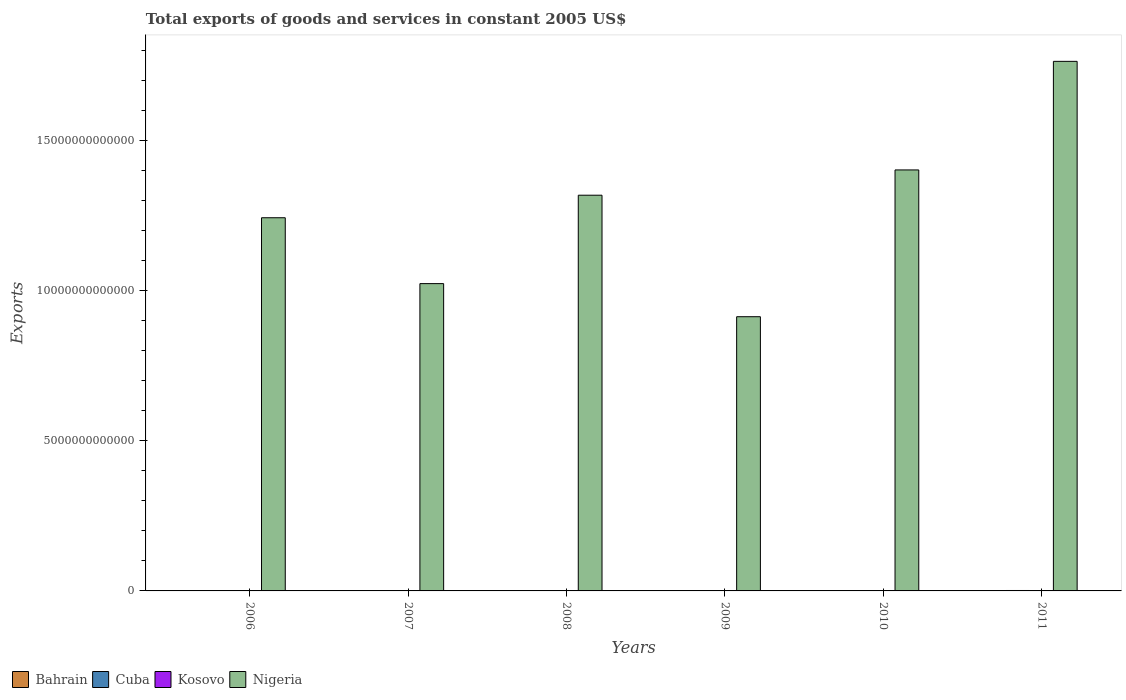What is the label of the 4th group of bars from the left?
Provide a short and direct response. 2009. What is the total exports of goods and services in Nigeria in 2009?
Offer a terse response. 9.13e+12. Across all years, what is the maximum total exports of goods and services in Cuba?
Keep it short and to the point. 1.41e+1. Across all years, what is the minimum total exports of goods and services in Bahrain?
Make the answer very short. 6.45e+09. In which year was the total exports of goods and services in Nigeria maximum?
Your answer should be very brief. 2011. What is the total total exports of goods and services in Bahrain in the graph?
Offer a terse response. 3.94e+1. What is the difference between the total exports of goods and services in Bahrain in 2006 and that in 2010?
Your answer should be compact. -2.68e+08. What is the difference between the total exports of goods and services in Nigeria in 2008 and the total exports of goods and services in Cuba in 2009?
Make the answer very short. 1.32e+13. What is the average total exports of goods and services in Cuba per year?
Provide a short and direct response. 1.17e+1. In the year 2011, what is the difference between the total exports of goods and services in Cuba and total exports of goods and services in Nigeria?
Make the answer very short. -1.76e+13. In how many years, is the total exports of goods and services in Nigeria greater than 3000000000000 US$?
Your answer should be very brief. 6. What is the ratio of the total exports of goods and services in Cuba in 2007 to that in 2011?
Give a very brief answer. 0.74. Is the total exports of goods and services in Cuba in 2008 less than that in 2011?
Your response must be concise. Yes. What is the difference between the highest and the second highest total exports of goods and services in Cuba?
Your answer should be compact. 5.28e+08. What is the difference between the highest and the lowest total exports of goods and services in Kosovo?
Offer a terse response. 3.19e+08. In how many years, is the total exports of goods and services in Nigeria greater than the average total exports of goods and services in Nigeria taken over all years?
Give a very brief answer. 3. Is the sum of the total exports of goods and services in Kosovo in 2009 and 2010 greater than the maximum total exports of goods and services in Nigeria across all years?
Provide a short and direct response. No. Is it the case that in every year, the sum of the total exports of goods and services in Kosovo and total exports of goods and services in Cuba is greater than the sum of total exports of goods and services in Bahrain and total exports of goods and services in Nigeria?
Ensure brevity in your answer.  No. What does the 3rd bar from the left in 2011 represents?
Your answer should be compact. Kosovo. What does the 2nd bar from the right in 2009 represents?
Your response must be concise. Kosovo. Is it the case that in every year, the sum of the total exports of goods and services in Bahrain and total exports of goods and services in Nigeria is greater than the total exports of goods and services in Cuba?
Your answer should be compact. Yes. How many bars are there?
Keep it short and to the point. 24. Are all the bars in the graph horizontal?
Ensure brevity in your answer.  No. How many years are there in the graph?
Your response must be concise. 6. What is the difference between two consecutive major ticks on the Y-axis?
Your response must be concise. 5.00e+12. Are the values on the major ticks of Y-axis written in scientific E-notation?
Offer a terse response. No. Does the graph contain any zero values?
Give a very brief answer. No. How are the legend labels stacked?
Make the answer very short. Horizontal. What is the title of the graph?
Your answer should be very brief. Total exports of goods and services in constant 2005 US$. What is the label or title of the Y-axis?
Your answer should be compact. Exports. What is the Exports of Bahrain in 2006?
Keep it short and to the point. 6.45e+09. What is the Exports in Cuba in 2006?
Offer a very short reply. 9.08e+09. What is the Exports of Kosovo in 2006?
Your response must be concise. 4.81e+08. What is the Exports in Nigeria in 2006?
Your answer should be very brief. 1.24e+13. What is the Exports in Bahrain in 2007?
Your answer should be very brief. 6.48e+09. What is the Exports of Cuba in 2007?
Your answer should be very brief. 1.03e+1. What is the Exports of Kosovo in 2007?
Offer a very short reply. 6.08e+08. What is the Exports of Nigeria in 2007?
Your response must be concise. 1.02e+13. What is the Exports of Bahrain in 2008?
Your answer should be compact. 6.53e+09. What is the Exports of Cuba in 2008?
Keep it short and to the point. 1.15e+1. What is the Exports of Kosovo in 2008?
Keep it short and to the point. 6.09e+08. What is the Exports of Nigeria in 2008?
Your answer should be compact. 1.32e+13. What is the Exports in Bahrain in 2009?
Give a very brief answer. 6.55e+09. What is the Exports of Cuba in 2009?
Provide a succinct answer. 1.19e+1. What is the Exports in Kosovo in 2009?
Offer a very short reply. 6.85e+08. What is the Exports in Nigeria in 2009?
Keep it short and to the point. 9.13e+12. What is the Exports of Bahrain in 2010?
Offer a terse response. 6.72e+09. What is the Exports of Cuba in 2010?
Make the answer very short. 1.35e+1. What is the Exports of Kosovo in 2010?
Your answer should be very brief. 7.70e+08. What is the Exports of Nigeria in 2010?
Give a very brief answer. 1.40e+13. What is the Exports in Bahrain in 2011?
Your answer should be very brief. 6.64e+09. What is the Exports in Cuba in 2011?
Provide a short and direct response. 1.41e+1. What is the Exports of Kosovo in 2011?
Provide a short and direct response. 8.00e+08. What is the Exports in Nigeria in 2011?
Your answer should be very brief. 1.76e+13. Across all years, what is the maximum Exports of Bahrain?
Your response must be concise. 6.72e+09. Across all years, what is the maximum Exports in Cuba?
Your response must be concise. 1.41e+1. Across all years, what is the maximum Exports in Kosovo?
Provide a succinct answer. 8.00e+08. Across all years, what is the maximum Exports of Nigeria?
Make the answer very short. 1.76e+13. Across all years, what is the minimum Exports in Bahrain?
Keep it short and to the point. 6.45e+09. Across all years, what is the minimum Exports in Cuba?
Offer a very short reply. 9.08e+09. Across all years, what is the minimum Exports in Kosovo?
Provide a succinct answer. 4.81e+08. Across all years, what is the minimum Exports of Nigeria?
Your answer should be compact. 9.13e+12. What is the total Exports of Bahrain in the graph?
Your answer should be very brief. 3.94e+1. What is the total Exports of Cuba in the graph?
Ensure brevity in your answer.  7.04e+1. What is the total Exports of Kosovo in the graph?
Ensure brevity in your answer.  3.95e+09. What is the total Exports in Nigeria in the graph?
Give a very brief answer. 7.66e+13. What is the difference between the Exports in Bahrain in 2006 and that in 2007?
Your answer should be compact. -2.92e+07. What is the difference between the Exports of Cuba in 2006 and that in 2007?
Provide a succinct answer. -1.25e+09. What is the difference between the Exports in Kosovo in 2006 and that in 2007?
Your answer should be compact. -1.27e+08. What is the difference between the Exports in Nigeria in 2006 and that in 2007?
Offer a terse response. 2.19e+12. What is the difference between the Exports in Bahrain in 2006 and that in 2008?
Your answer should be compact. -7.32e+07. What is the difference between the Exports of Cuba in 2006 and that in 2008?
Make the answer very short. -2.45e+09. What is the difference between the Exports in Kosovo in 2006 and that in 2008?
Your answer should be very brief. -1.28e+08. What is the difference between the Exports in Nigeria in 2006 and that in 2008?
Offer a terse response. -7.50e+11. What is the difference between the Exports in Bahrain in 2006 and that in 2009?
Offer a very short reply. -9.60e+07. What is the difference between the Exports of Cuba in 2006 and that in 2009?
Your answer should be compact. -2.81e+09. What is the difference between the Exports of Kosovo in 2006 and that in 2009?
Provide a succinct answer. -2.03e+08. What is the difference between the Exports of Nigeria in 2006 and that in 2009?
Your answer should be compact. 3.29e+12. What is the difference between the Exports in Bahrain in 2006 and that in 2010?
Offer a terse response. -2.68e+08. What is the difference between the Exports of Cuba in 2006 and that in 2010?
Your answer should be compact. -4.45e+09. What is the difference between the Exports of Kosovo in 2006 and that in 2010?
Offer a terse response. -2.89e+08. What is the difference between the Exports of Nigeria in 2006 and that in 2010?
Your answer should be very brief. -1.59e+12. What is the difference between the Exports in Bahrain in 2006 and that in 2011?
Your answer should be compact. -1.88e+08. What is the difference between the Exports of Cuba in 2006 and that in 2011?
Make the answer very short. -4.98e+09. What is the difference between the Exports of Kosovo in 2006 and that in 2011?
Ensure brevity in your answer.  -3.19e+08. What is the difference between the Exports of Nigeria in 2006 and that in 2011?
Keep it short and to the point. -5.21e+12. What is the difference between the Exports in Bahrain in 2007 and that in 2008?
Make the answer very short. -4.40e+07. What is the difference between the Exports in Cuba in 2007 and that in 2008?
Your answer should be very brief. -1.20e+09. What is the difference between the Exports in Kosovo in 2007 and that in 2008?
Your answer should be compact. -5.00e+05. What is the difference between the Exports in Nigeria in 2007 and that in 2008?
Ensure brevity in your answer.  -2.94e+12. What is the difference between the Exports in Bahrain in 2007 and that in 2009?
Make the answer very short. -6.68e+07. What is the difference between the Exports of Cuba in 2007 and that in 2009?
Keep it short and to the point. -1.56e+09. What is the difference between the Exports in Kosovo in 2007 and that in 2009?
Your response must be concise. -7.64e+07. What is the difference between the Exports in Nigeria in 2007 and that in 2009?
Provide a short and direct response. 1.10e+12. What is the difference between the Exports of Bahrain in 2007 and that in 2010?
Give a very brief answer. -2.39e+08. What is the difference between the Exports in Cuba in 2007 and that in 2010?
Give a very brief answer. -3.20e+09. What is the difference between the Exports of Kosovo in 2007 and that in 2010?
Give a very brief answer. -1.62e+08. What is the difference between the Exports in Nigeria in 2007 and that in 2010?
Ensure brevity in your answer.  -3.78e+12. What is the difference between the Exports in Bahrain in 2007 and that in 2011?
Offer a terse response. -1.59e+08. What is the difference between the Exports in Cuba in 2007 and that in 2011?
Give a very brief answer. -3.72e+09. What is the difference between the Exports of Kosovo in 2007 and that in 2011?
Give a very brief answer. -1.92e+08. What is the difference between the Exports in Nigeria in 2007 and that in 2011?
Provide a succinct answer. -7.40e+12. What is the difference between the Exports in Bahrain in 2008 and that in 2009?
Your answer should be very brief. -2.28e+07. What is the difference between the Exports in Cuba in 2008 and that in 2009?
Ensure brevity in your answer.  -3.59e+08. What is the difference between the Exports in Kosovo in 2008 and that in 2009?
Provide a succinct answer. -7.59e+07. What is the difference between the Exports of Nigeria in 2008 and that in 2009?
Your answer should be very brief. 4.04e+12. What is the difference between the Exports in Bahrain in 2008 and that in 2010?
Ensure brevity in your answer.  -1.95e+08. What is the difference between the Exports in Cuba in 2008 and that in 2010?
Your answer should be very brief. -2.00e+09. What is the difference between the Exports of Kosovo in 2008 and that in 2010?
Offer a terse response. -1.62e+08. What is the difference between the Exports in Nigeria in 2008 and that in 2010?
Make the answer very short. -8.42e+11. What is the difference between the Exports of Bahrain in 2008 and that in 2011?
Keep it short and to the point. -1.15e+08. What is the difference between the Exports of Cuba in 2008 and that in 2011?
Provide a short and direct response. -2.53e+09. What is the difference between the Exports of Kosovo in 2008 and that in 2011?
Your response must be concise. -1.91e+08. What is the difference between the Exports in Nigeria in 2008 and that in 2011?
Give a very brief answer. -4.46e+12. What is the difference between the Exports of Bahrain in 2009 and that in 2010?
Your answer should be compact. -1.72e+08. What is the difference between the Exports of Cuba in 2009 and that in 2010?
Make the answer very short. -1.64e+09. What is the difference between the Exports in Kosovo in 2009 and that in 2010?
Offer a terse response. -8.56e+07. What is the difference between the Exports in Nigeria in 2009 and that in 2010?
Make the answer very short. -4.89e+12. What is the difference between the Exports of Bahrain in 2009 and that in 2011?
Keep it short and to the point. -9.23e+07. What is the difference between the Exports in Cuba in 2009 and that in 2011?
Keep it short and to the point. -2.17e+09. What is the difference between the Exports of Kosovo in 2009 and that in 2011?
Offer a very short reply. -1.15e+08. What is the difference between the Exports of Nigeria in 2009 and that in 2011?
Provide a succinct answer. -8.50e+12. What is the difference between the Exports in Bahrain in 2010 and that in 2011?
Make the answer very short. 8.00e+07. What is the difference between the Exports of Cuba in 2010 and that in 2011?
Make the answer very short. -5.28e+08. What is the difference between the Exports of Kosovo in 2010 and that in 2011?
Offer a very short reply. -2.96e+07. What is the difference between the Exports in Nigeria in 2010 and that in 2011?
Make the answer very short. -3.61e+12. What is the difference between the Exports of Bahrain in 2006 and the Exports of Cuba in 2007?
Provide a short and direct response. -3.88e+09. What is the difference between the Exports of Bahrain in 2006 and the Exports of Kosovo in 2007?
Ensure brevity in your answer.  5.85e+09. What is the difference between the Exports of Bahrain in 2006 and the Exports of Nigeria in 2007?
Provide a succinct answer. -1.02e+13. What is the difference between the Exports of Cuba in 2006 and the Exports of Kosovo in 2007?
Provide a short and direct response. 8.47e+09. What is the difference between the Exports of Cuba in 2006 and the Exports of Nigeria in 2007?
Ensure brevity in your answer.  -1.02e+13. What is the difference between the Exports of Kosovo in 2006 and the Exports of Nigeria in 2007?
Your answer should be very brief. -1.02e+13. What is the difference between the Exports in Bahrain in 2006 and the Exports in Cuba in 2008?
Your answer should be very brief. -5.08e+09. What is the difference between the Exports in Bahrain in 2006 and the Exports in Kosovo in 2008?
Offer a terse response. 5.85e+09. What is the difference between the Exports in Bahrain in 2006 and the Exports in Nigeria in 2008?
Provide a succinct answer. -1.32e+13. What is the difference between the Exports of Cuba in 2006 and the Exports of Kosovo in 2008?
Provide a succinct answer. 8.47e+09. What is the difference between the Exports of Cuba in 2006 and the Exports of Nigeria in 2008?
Offer a terse response. -1.32e+13. What is the difference between the Exports in Kosovo in 2006 and the Exports in Nigeria in 2008?
Ensure brevity in your answer.  -1.32e+13. What is the difference between the Exports of Bahrain in 2006 and the Exports of Cuba in 2009?
Offer a very short reply. -5.44e+09. What is the difference between the Exports of Bahrain in 2006 and the Exports of Kosovo in 2009?
Provide a short and direct response. 5.77e+09. What is the difference between the Exports in Bahrain in 2006 and the Exports in Nigeria in 2009?
Keep it short and to the point. -9.12e+12. What is the difference between the Exports in Cuba in 2006 and the Exports in Kosovo in 2009?
Provide a succinct answer. 8.40e+09. What is the difference between the Exports in Cuba in 2006 and the Exports in Nigeria in 2009?
Your answer should be compact. -9.12e+12. What is the difference between the Exports in Kosovo in 2006 and the Exports in Nigeria in 2009?
Give a very brief answer. -9.13e+12. What is the difference between the Exports of Bahrain in 2006 and the Exports of Cuba in 2010?
Offer a terse response. -7.08e+09. What is the difference between the Exports of Bahrain in 2006 and the Exports of Kosovo in 2010?
Give a very brief answer. 5.68e+09. What is the difference between the Exports in Bahrain in 2006 and the Exports in Nigeria in 2010?
Your response must be concise. -1.40e+13. What is the difference between the Exports in Cuba in 2006 and the Exports in Kosovo in 2010?
Offer a very short reply. 8.31e+09. What is the difference between the Exports of Cuba in 2006 and the Exports of Nigeria in 2010?
Keep it short and to the point. -1.40e+13. What is the difference between the Exports of Kosovo in 2006 and the Exports of Nigeria in 2010?
Offer a very short reply. -1.40e+13. What is the difference between the Exports of Bahrain in 2006 and the Exports of Cuba in 2011?
Provide a short and direct response. -7.60e+09. What is the difference between the Exports of Bahrain in 2006 and the Exports of Kosovo in 2011?
Your answer should be very brief. 5.65e+09. What is the difference between the Exports of Bahrain in 2006 and the Exports of Nigeria in 2011?
Offer a terse response. -1.76e+13. What is the difference between the Exports in Cuba in 2006 and the Exports in Kosovo in 2011?
Your answer should be compact. 8.28e+09. What is the difference between the Exports in Cuba in 2006 and the Exports in Nigeria in 2011?
Ensure brevity in your answer.  -1.76e+13. What is the difference between the Exports of Kosovo in 2006 and the Exports of Nigeria in 2011?
Your answer should be very brief. -1.76e+13. What is the difference between the Exports in Bahrain in 2007 and the Exports in Cuba in 2008?
Ensure brevity in your answer.  -5.05e+09. What is the difference between the Exports of Bahrain in 2007 and the Exports of Kosovo in 2008?
Provide a short and direct response. 5.87e+09. What is the difference between the Exports in Bahrain in 2007 and the Exports in Nigeria in 2008?
Provide a short and direct response. -1.32e+13. What is the difference between the Exports in Cuba in 2007 and the Exports in Kosovo in 2008?
Offer a very short reply. 9.73e+09. What is the difference between the Exports in Cuba in 2007 and the Exports in Nigeria in 2008?
Offer a terse response. -1.32e+13. What is the difference between the Exports of Kosovo in 2007 and the Exports of Nigeria in 2008?
Offer a very short reply. -1.32e+13. What is the difference between the Exports in Bahrain in 2007 and the Exports in Cuba in 2009?
Your answer should be very brief. -5.41e+09. What is the difference between the Exports in Bahrain in 2007 and the Exports in Kosovo in 2009?
Make the answer very short. 5.80e+09. What is the difference between the Exports of Bahrain in 2007 and the Exports of Nigeria in 2009?
Keep it short and to the point. -9.12e+12. What is the difference between the Exports in Cuba in 2007 and the Exports in Kosovo in 2009?
Make the answer very short. 9.65e+09. What is the difference between the Exports of Cuba in 2007 and the Exports of Nigeria in 2009?
Offer a very short reply. -9.12e+12. What is the difference between the Exports of Kosovo in 2007 and the Exports of Nigeria in 2009?
Your answer should be very brief. -9.13e+12. What is the difference between the Exports in Bahrain in 2007 and the Exports in Cuba in 2010?
Your response must be concise. -7.05e+09. What is the difference between the Exports of Bahrain in 2007 and the Exports of Kosovo in 2010?
Your response must be concise. 5.71e+09. What is the difference between the Exports in Bahrain in 2007 and the Exports in Nigeria in 2010?
Offer a very short reply. -1.40e+13. What is the difference between the Exports in Cuba in 2007 and the Exports in Kosovo in 2010?
Give a very brief answer. 9.56e+09. What is the difference between the Exports of Cuba in 2007 and the Exports of Nigeria in 2010?
Your response must be concise. -1.40e+13. What is the difference between the Exports in Kosovo in 2007 and the Exports in Nigeria in 2010?
Give a very brief answer. -1.40e+13. What is the difference between the Exports in Bahrain in 2007 and the Exports in Cuba in 2011?
Make the answer very short. -7.57e+09. What is the difference between the Exports in Bahrain in 2007 and the Exports in Kosovo in 2011?
Your answer should be very brief. 5.68e+09. What is the difference between the Exports in Bahrain in 2007 and the Exports in Nigeria in 2011?
Offer a terse response. -1.76e+13. What is the difference between the Exports of Cuba in 2007 and the Exports of Kosovo in 2011?
Keep it short and to the point. 9.53e+09. What is the difference between the Exports in Cuba in 2007 and the Exports in Nigeria in 2011?
Ensure brevity in your answer.  -1.76e+13. What is the difference between the Exports of Kosovo in 2007 and the Exports of Nigeria in 2011?
Your answer should be very brief. -1.76e+13. What is the difference between the Exports of Bahrain in 2008 and the Exports of Cuba in 2009?
Offer a terse response. -5.36e+09. What is the difference between the Exports in Bahrain in 2008 and the Exports in Kosovo in 2009?
Give a very brief answer. 5.84e+09. What is the difference between the Exports of Bahrain in 2008 and the Exports of Nigeria in 2009?
Offer a terse response. -9.12e+12. What is the difference between the Exports of Cuba in 2008 and the Exports of Kosovo in 2009?
Give a very brief answer. 1.08e+1. What is the difference between the Exports of Cuba in 2008 and the Exports of Nigeria in 2009?
Your response must be concise. -9.12e+12. What is the difference between the Exports of Kosovo in 2008 and the Exports of Nigeria in 2009?
Keep it short and to the point. -9.13e+12. What is the difference between the Exports in Bahrain in 2008 and the Exports in Cuba in 2010?
Offer a very short reply. -7.00e+09. What is the difference between the Exports in Bahrain in 2008 and the Exports in Kosovo in 2010?
Keep it short and to the point. 5.76e+09. What is the difference between the Exports of Bahrain in 2008 and the Exports of Nigeria in 2010?
Offer a very short reply. -1.40e+13. What is the difference between the Exports of Cuba in 2008 and the Exports of Kosovo in 2010?
Offer a very short reply. 1.08e+1. What is the difference between the Exports of Cuba in 2008 and the Exports of Nigeria in 2010?
Provide a succinct answer. -1.40e+13. What is the difference between the Exports of Kosovo in 2008 and the Exports of Nigeria in 2010?
Ensure brevity in your answer.  -1.40e+13. What is the difference between the Exports of Bahrain in 2008 and the Exports of Cuba in 2011?
Offer a terse response. -7.53e+09. What is the difference between the Exports in Bahrain in 2008 and the Exports in Kosovo in 2011?
Offer a very short reply. 5.73e+09. What is the difference between the Exports in Bahrain in 2008 and the Exports in Nigeria in 2011?
Your answer should be compact. -1.76e+13. What is the difference between the Exports of Cuba in 2008 and the Exports of Kosovo in 2011?
Give a very brief answer. 1.07e+1. What is the difference between the Exports of Cuba in 2008 and the Exports of Nigeria in 2011?
Ensure brevity in your answer.  -1.76e+13. What is the difference between the Exports of Kosovo in 2008 and the Exports of Nigeria in 2011?
Your response must be concise. -1.76e+13. What is the difference between the Exports in Bahrain in 2009 and the Exports in Cuba in 2010?
Your response must be concise. -6.98e+09. What is the difference between the Exports in Bahrain in 2009 and the Exports in Kosovo in 2010?
Offer a terse response. 5.78e+09. What is the difference between the Exports of Bahrain in 2009 and the Exports of Nigeria in 2010?
Provide a short and direct response. -1.40e+13. What is the difference between the Exports in Cuba in 2009 and the Exports in Kosovo in 2010?
Offer a terse response. 1.11e+1. What is the difference between the Exports of Cuba in 2009 and the Exports of Nigeria in 2010?
Provide a succinct answer. -1.40e+13. What is the difference between the Exports in Kosovo in 2009 and the Exports in Nigeria in 2010?
Make the answer very short. -1.40e+13. What is the difference between the Exports in Bahrain in 2009 and the Exports in Cuba in 2011?
Keep it short and to the point. -7.51e+09. What is the difference between the Exports in Bahrain in 2009 and the Exports in Kosovo in 2011?
Your response must be concise. 5.75e+09. What is the difference between the Exports in Bahrain in 2009 and the Exports in Nigeria in 2011?
Your response must be concise. -1.76e+13. What is the difference between the Exports of Cuba in 2009 and the Exports of Kosovo in 2011?
Your answer should be compact. 1.11e+1. What is the difference between the Exports in Cuba in 2009 and the Exports in Nigeria in 2011?
Keep it short and to the point. -1.76e+13. What is the difference between the Exports in Kosovo in 2009 and the Exports in Nigeria in 2011?
Provide a short and direct response. -1.76e+13. What is the difference between the Exports of Bahrain in 2010 and the Exports of Cuba in 2011?
Offer a very short reply. -7.34e+09. What is the difference between the Exports of Bahrain in 2010 and the Exports of Kosovo in 2011?
Your response must be concise. 5.92e+09. What is the difference between the Exports of Bahrain in 2010 and the Exports of Nigeria in 2011?
Give a very brief answer. -1.76e+13. What is the difference between the Exports of Cuba in 2010 and the Exports of Kosovo in 2011?
Keep it short and to the point. 1.27e+1. What is the difference between the Exports of Cuba in 2010 and the Exports of Nigeria in 2011?
Keep it short and to the point. -1.76e+13. What is the difference between the Exports of Kosovo in 2010 and the Exports of Nigeria in 2011?
Offer a terse response. -1.76e+13. What is the average Exports in Bahrain per year?
Your response must be concise. 6.56e+09. What is the average Exports in Cuba per year?
Offer a terse response. 1.17e+1. What is the average Exports in Kosovo per year?
Your response must be concise. 6.59e+08. What is the average Exports of Nigeria per year?
Provide a short and direct response. 1.28e+13. In the year 2006, what is the difference between the Exports of Bahrain and Exports of Cuba?
Offer a terse response. -2.63e+09. In the year 2006, what is the difference between the Exports of Bahrain and Exports of Kosovo?
Your answer should be compact. 5.97e+09. In the year 2006, what is the difference between the Exports of Bahrain and Exports of Nigeria?
Make the answer very short. -1.24e+13. In the year 2006, what is the difference between the Exports of Cuba and Exports of Kosovo?
Provide a succinct answer. 8.60e+09. In the year 2006, what is the difference between the Exports in Cuba and Exports in Nigeria?
Offer a terse response. -1.24e+13. In the year 2006, what is the difference between the Exports in Kosovo and Exports in Nigeria?
Offer a terse response. -1.24e+13. In the year 2007, what is the difference between the Exports of Bahrain and Exports of Cuba?
Your answer should be very brief. -3.85e+09. In the year 2007, what is the difference between the Exports of Bahrain and Exports of Kosovo?
Provide a succinct answer. 5.88e+09. In the year 2007, what is the difference between the Exports of Bahrain and Exports of Nigeria?
Provide a short and direct response. -1.02e+13. In the year 2007, what is the difference between the Exports of Cuba and Exports of Kosovo?
Give a very brief answer. 9.73e+09. In the year 2007, what is the difference between the Exports of Cuba and Exports of Nigeria?
Ensure brevity in your answer.  -1.02e+13. In the year 2007, what is the difference between the Exports in Kosovo and Exports in Nigeria?
Offer a very short reply. -1.02e+13. In the year 2008, what is the difference between the Exports in Bahrain and Exports in Cuba?
Give a very brief answer. -5.00e+09. In the year 2008, what is the difference between the Exports of Bahrain and Exports of Kosovo?
Offer a very short reply. 5.92e+09. In the year 2008, what is the difference between the Exports of Bahrain and Exports of Nigeria?
Offer a terse response. -1.32e+13. In the year 2008, what is the difference between the Exports in Cuba and Exports in Kosovo?
Make the answer very short. 1.09e+1. In the year 2008, what is the difference between the Exports in Cuba and Exports in Nigeria?
Make the answer very short. -1.32e+13. In the year 2008, what is the difference between the Exports of Kosovo and Exports of Nigeria?
Provide a succinct answer. -1.32e+13. In the year 2009, what is the difference between the Exports of Bahrain and Exports of Cuba?
Your answer should be very brief. -5.34e+09. In the year 2009, what is the difference between the Exports of Bahrain and Exports of Kosovo?
Offer a terse response. 5.87e+09. In the year 2009, what is the difference between the Exports in Bahrain and Exports in Nigeria?
Provide a short and direct response. -9.12e+12. In the year 2009, what is the difference between the Exports of Cuba and Exports of Kosovo?
Your response must be concise. 1.12e+1. In the year 2009, what is the difference between the Exports of Cuba and Exports of Nigeria?
Give a very brief answer. -9.12e+12. In the year 2009, what is the difference between the Exports of Kosovo and Exports of Nigeria?
Offer a very short reply. -9.13e+12. In the year 2010, what is the difference between the Exports in Bahrain and Exports in Cuba?
Your answer should be very brief. -6.81e+09. In the year 2010, what is the difference between the Exports in Bahrain and Exports in Kosovo?
Your response must be concise. 5.95e+09. In the year 2010, what is the difference between the Exports in Bahrain and Exports in Nigeria?
Your answer should be very brief. -1.40e+13. In the year 2010, what is the difference between the Exports of Cuba and Exports of Kosovo?
Your response must be concise. 1.28e+1. In the year 2010, what is the difference between the Exports in Cuba and Exports in Nigeria?
Make the answer very short. -1.40e+13. In the year 2010, what is the difference between the Exports in Kosovo and Exports in Nigeria?
Offer a very short reply. -1.40e+13. In the year 2011, what is the difference between the Exports in Bahrain and Exports in Cuba?
Offer a very short reply. -7.42e+09. In the year 2011, what is the difference between the Exports in Bahrain and Exports in Kosovo?
Ensure brevity in your answer.  5.84e+09. In the year 2011, what is the difference between the Exports of Bahrain and Exports of Nigeria?
Your answer should be compact. -1.76e+13. In the year 2011, what is the difference between the Exports of Cuba and Exports of Kosovo?
Ensure brevity in your answer.  1.33e+1. In the year 2011, what is the difference between the Exports in Cuba and Exports in Nigeria?
Give a very brief answer. -1.76e+13. In the year 2011, what is the difference between the Exports of Kosovo and Exports of Nigeria?
Ensure brevity in your answer.  -1.76e+13. What is the ratio of the Exports in Cuba in 2006 to that in 2007?
Make the answer very short. 0.88. What is the ratio of the Exports of Kosovo in 2006 to that in 2007?
Offer a terse response. 0.79. What is the ratio of the Exports of Nigeria in 2006 to that in 2007?
Offer a very short reply. 1.21. What is the ratio of the Exports of Bahrain in 2006 to that in 2008?
Your answer should be very brief. 0.99. What is the ratio of the Exports in Cuba in 2006 to that in 2008?
Provide a succinct answer. 0.79. What is the ratio of the Exports of Kosovo in 2006 to that in 2008?
Offer a very short reply. 0.79. What is the ratio of the Exports of Nigeria in 2006 to that in 2008?
Offer a terse response. 0.94. What is the ratio of the Exports of Bahrain in 2006 to that in 2009?
Give a very brief answer. 0.99. What is the ratio of the Exports of Cuba in 2006 to that in 2009?
Keep it short and to the point. 0.76. What is the ratio of the Exports of Kosovo in 2006 to that in 2009?
Make the answer very short. 0.7. What is the ratio of the Exports of Nigeria in 2006 to that in 2009?
Provide a short and direct response. 1.36. What is the ratio of the Exports in Bahrain in 2006 to that in 2010?
Your response must be concise. 0.96. What is the ratio of the Exports of Cuba in 2006 to that in 2010?
Provide a short and direct response. 0.67. What is the ratio of the Exports in Kosovo in 2006 to that in 2010?
Ensure brevity in your answer.  0.62. What is the ratio of the Exports of Nigeria in 2006 to that in 2010?
Your response must be concise. 0.89. What is the ratio of the Exports of Bahrain in 2006 to that in 2011?
Offer a very short reply. 0.97. What is the ratio of the Exports of Cuba in 2006 to that in 2011?
Provide a short and direct response. 0.65. What is the ratio of the Exports in Kosovo in 2006 to that in 2011?
Give a very brief answer. 0.6. What is the ratio of the Exports in Nigeria in 2006 to that in 2011?
Give a very brief answer. 0.7. What is the ratio of the Exports of Cuba in 2007 to that in 2008?
Provide a succinct answer. 0.9. What is the ratio of the Exports of Kosovo in 2007 to that in 2008?
Keep it short and to the point. 1. What is the ratio of the Exports of Nigeria in 2007 to that in 2008?
Your answer should be compact. 0.78. What is the ratio of the Exports in Cuba in 2007 to that in 2009?
Your answer should be compact. 0.87. What is the ratio of the Exports of Kosovo in 2007 to that in 2009?
Offer a very short reply. 0.89. What is the ratio of the Exports in Nigeria in 2007 to that in 2009?
Provide a succinct answer. 1.12. What is the ratio of the Exports of Bahrain in 2007 to that in 2010?
Keep it short and to the point. 0.96. What is the ratio of the Exports in Cuba in 2007 to that in 2010?
Offer a very short reply. 0.76. What is the ratio of the Exports of Kosovo in 2007 to that in 2010?
Your response must be concise. 0.79. What is the ratio of the Exports of Nigeria in 2007 to that in 2010?
Your answer should be compact. 0.73. What is the ratio of the Exports in Cuba in 2007 to that in 2011?
Your answer should be compact. 0.74. What is the ratio of the Exports in Kosovo in 2007 to that in 2011?
Provide a succinct answer. 0.76. What is the ratio of the Exports of Nigeria in 2007 to that in 2011?
Give a very brief answer. 0.58. What is the ratio of the Exports in Bahrain in 2008 to that in 2009?
Make the answer very short. 1. What is the ratio of the Exports in Cuba in 2008 to that in 2009?
Your response must be concise. 0.97. What is the ratio of the Exports in Kosovo in 2008 to that in 2009?
Your response must be concise. 0.89. What is the ratio of the Exports of Nigeria in 2008 to that in 2009?
Your response must be concise. 1.44. What is the ratio of the Exports in Cuba in 2008 to that in 2010?
Keep it short and to the point. 0.85. What is the ratio of the Exports in Kosovo in 2008 to that in 2010?
Keep it short and to the point. 0.79. What is the ratio of the Exports in Nigeria in 2008 to that in 2010?
Keep it short and to the point. 0.94. What is the ratio of the Exports of Bahrain in 2008 to that in 2011?
Your response must be concise. 0.98. What is the ratio of the Exports in Cuba in 2008 to that in 2011?
Offer a very short reply. 0.82. What is the ratio of the Exports of Kosovo in 2008 to that in 2011?
Keep it short and to the point. 0.76. What is the ratio of the Exports in Nigeria in 2008 to that in 2011?
Ensure brevity in your answer.  0.75. What is the ratio of the Exports of Bahrain in 2009 to that in 2010?
Give a very brief answer. 0.97. What is the ratio of the Exports of Cuba in 2009 to that in 2010?
Your response must be concise. 0.88. What is the ratio of the Exports of Kosovo in 2009 to that in 2010?
Your response must be concise. 0.89. What is the ratio of the Exports in Nigeria in 2009 to that in 2010?
Offer a very short reply. 0.65. What is the ratio of the Exports in Bahrain in 2009 to that in 2011?
Your answer should be compact. 0.99. What is the ratio of the Exports in Cuba in 2009 to that in 2011?
Ensure brevity in your answer.  0.85. What is the ratio of the Exports of Kosovo in 2009 to that in 2011?
Offer a terse response. 0.86. What is the ratio of the Exports in Nigeria in 2009 to that in 2011?
Offer a very short reply. 0.52. What is the ratio of the Exports of Bahrain in 2010 to that in 2011?
Make the answer very short. 1.01. What is the ratio of the Exports in Cuba in 2010 to that in 2011?
Provide a succinct answer. 0.96. What is the ratio of the Exports in Kosovo in 2010 to that in 2011?
Provide a short and direct response. 0.96. What is the ratio of the Exports of Nigeria in 2010 to that in 2011?
Your response must be concise. 0.8. What is the difference between the highest and the second highest Exports in Bahrain?
Your answer should be compact. 8.00e+07. What is the difference between the highest and the second highest Exports of Cuba?
Offer a terse response. 5.28e+08. What is the difference between the highest and the second highest Exports in Kosovo?
Your response must be concise. 2.96e+07. What is the difference between the highest and the second highest Exports of Nigeria?
Offer a very short reply. 3.61e+12. What is the difference between the highest and the lowest Exports in Bahrain?
Your answer should be compact. 2.68e+08. What is the difference between the highest and the lowest Exports in Cuba?
Provide a succinct answer. 4.98e+09. What is the difference between the highest and the lowest Exports of Kosovo?
Give a very brief answer. 3.19e+08. What is the difference between the highest and the lowest Exports in Nigeria?
Give a very brief answer. 8.50e+12. 